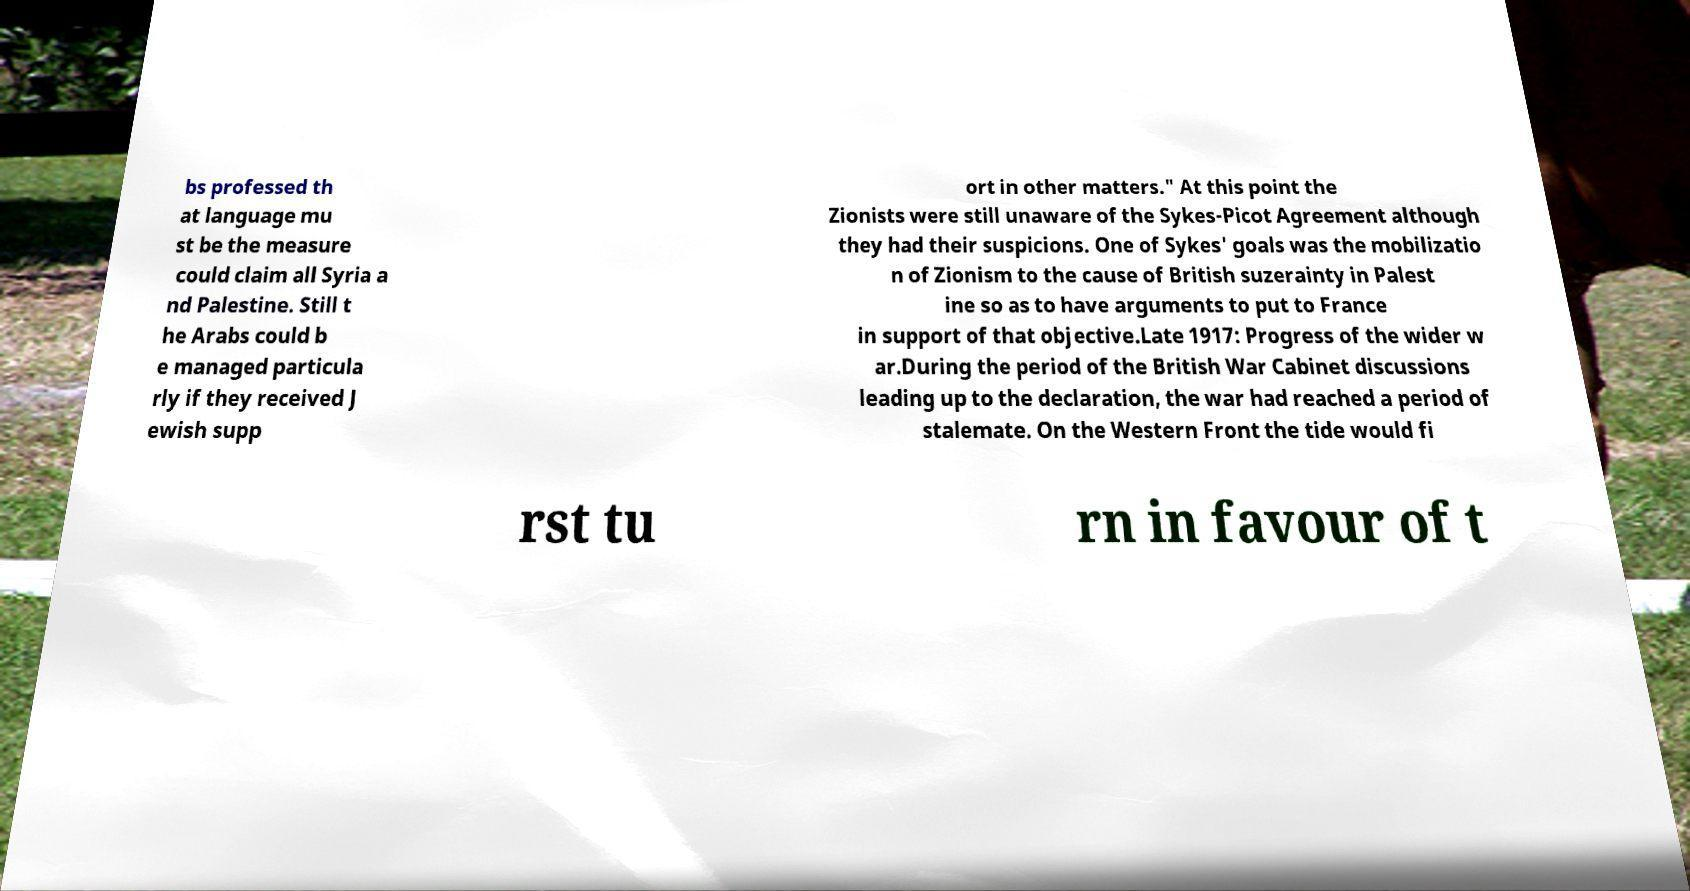For documentation purposes, I need the text within this image transcribed. Could you provide that? bs professed th at language mu st be the measure could claim all Syria a nd Palestine. Still t he Arabs could b e managed particula rly if they received J ewish supp ort in other matters." At this point the Zionists were still unaware of the Sykes-Picot Agreement although they had their suspicions. One of Sykes' goals was the mobilizatio n of Zionism to the cause of British suzerainty in Palest ine so as to have arguments to put to France in support of that objective.Late 1917: Progress of the wider w ar.During the period of the British War Cabinet discussions leading up to the declaration, the war had reached a period of stalemate. On the Western Front the tide would fi rst tu rn in favour of t 